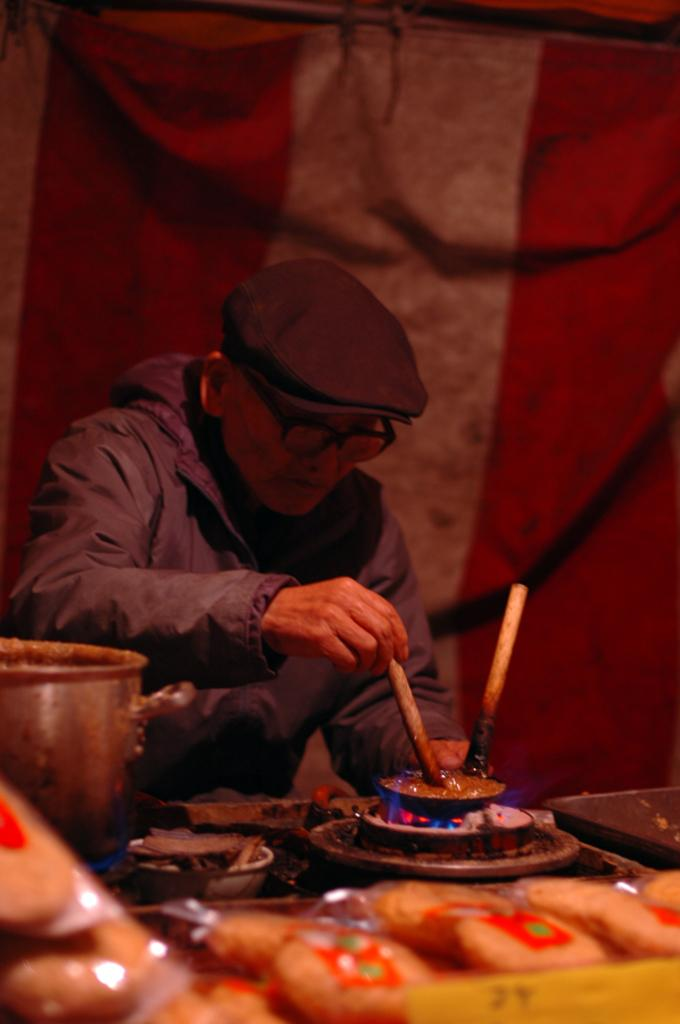What can be seen in the image? There is a person in the image. Can you describe the person's appearance? The person is wearing a cap and spectacles. What is the person doing in the image? The person is standing in front of a gas stove. What is on the table in front of the person? There are bowls and other objects in front of the person. What can be seen in the background of the image? There is a cloth visible in the background. Is the person in the image a fireman? There is no indication in the image that the person is a fireman. Does the person have a partner in the image? There is no mention of a partner in the image. 